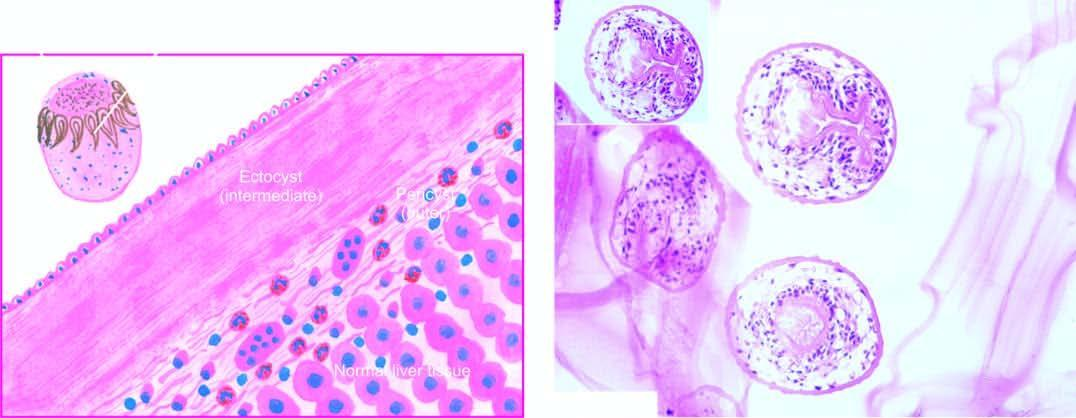how does inbox in the right photomicrograph show a scolex?
Answer the question using a single word or phrase. With a row of hooklets 